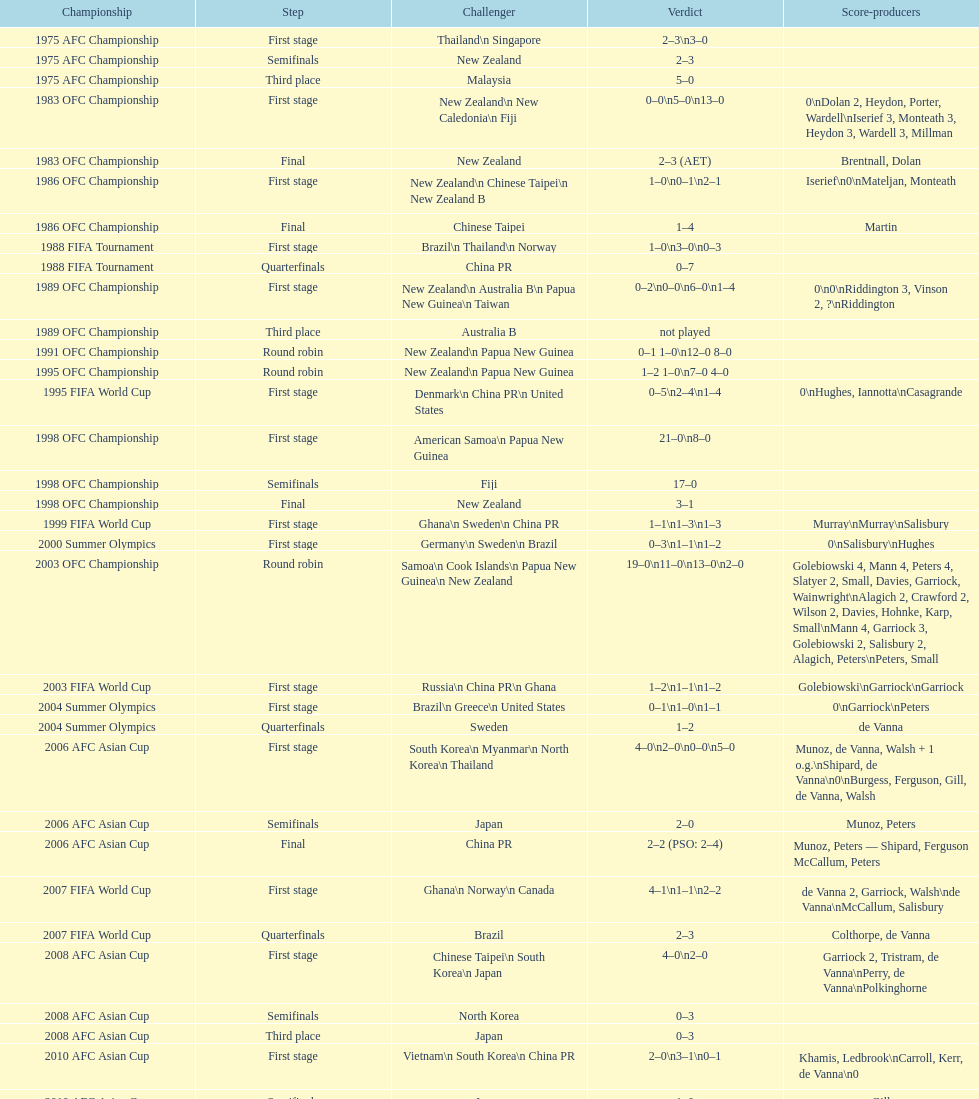How many points were scored in the final round of the 2012 summer olympics afc qualification? 12. Would you mind parsing the complete table? {'header': ['Championship', 'Step', 'Challenger', 'Verdict', 'Score-producers'], 'rows': [['1975 AFC Championship', 'First stage', 'Thailand\\n\xa0Singapore', '2–3\\n3–0', ''], ['1975 AFC Championship', 'Semifinals', 'New Zealand', '2–3', ''], ['1975 AFC Championship', 'Third place', 'Malaysia', '5–0', ''], ['1983 OFC Championship', 'First stage', 'New Zealand\\n\xa0New Caledonia\\n\xa0Fiji', '0–0\\n5–0\\n13–0', '0\\nDolan 2, Heydon, Porter, Wardell\\nIserief 3, Monteath 3, Heydon 3, Wardell 3, Millman'], ['1983 OFC Championship', 'Final', 'New Zealand', '2–3 (AET)', 'Brentnall, Dolan'], ['1986 OFC Championship', 'First stage', 'New Zealand\\n\xa0Chinese Taipei\\n New Zealand B', '1–0\\n0–1\\n2–1', 'Iserief\\n0\\nMateljan, Monteath'], ['1986 OFC Championship', 'Final', 'Chinese Taipei', '1–4', 'Martin'], ['1988 FIFA Tournament', 'First stage', 'Brazil\\n\xa0Thailand\\n\xa0Norway', '1–0\\n3–0\\n0–3', ''], ['1988 FIFA Tournament', 'Quarterfinals', 'China PR', '0–7', ''], ['1989 OFC Championship', 'First stage', 'New Zealand\\n Australia B\\n\xa0Papua New Guinea\\n\xa0Taiwan', '0–2\\n0–0\\n6–0\\n1–4', '0\\n0\\nRiddington 3, Vinson 2,\xa0?\\nRiddington'], ['1989 OFC Championship', 'Third place', 'Australia B', 'not played', ''], ['1991 OFC Championship', 'Round robin', 'New Zealand\\n\xa0Papua New Guinea', '0–1 1–0\\n12–0 8–0', ''], ['1995 OFC Championship', 'Round robin', 'New Zealand\\n\xa0Papua New Guinea', '1–2 1–0\\n7–0 4–0', ''], ['1995 FIFA World Cup', 'First stage', 'Denmark\\n\xa0China PR\\n\xa0United States', '0–5\\n2–4\\n1–4', '0\\nHughes, Iannotta\\nCasagrande'], ['1998 OFC Championship', 'First stage', 'American Samoa\\n\xa0Papua New Guinea', '21–0\\n8–0', ''], ['1998 OFC Championship', 'Semifinals', 'Fiji', '17–0', ''], ['1998 OFC Championship', 'Final', 'New Zealand', '3–1', ''], ['1999 FIFA World Cup', 'First stage', 'Ghana\\n\xa0Sweden\\n\xa0China PR', '1–1\\n1–3\\n1–3', 'Murray\\nMurray\\nSalisbury'], ['2000 Summer Olympics', 'First stage', 'Germany\\n\xa0Sweden\\n\xa0Brazil', '0–3\\n1–1\\n1–2', '0\\nSalisbury\\nHughes'], ['2003 OFC Championship', 'Round robin', 'Samoa\\n\xa0Cook Islands\\n\xa0Papua New Guinea\\n\xa0New Zealand', '19–0\\n11–0\\n13–0\\n2–0', 'Golebiowski 4, Mann 4, Peters 4, Slatyer 2, Small, Davies, Garriock, Wainwright\\nAlagich 2, Crawford 2, Wilson 2, Davies, Hohnke, Karp, Small\\nMann 4, Garriock 3, Golebiowski 2, Salisbury 2, Alagich, Peters\\nPeters, Small'], ['2003 FIFA World Cup', 'First stage', 'Russia\\n\xa0China PR\\n\xa0Ghana', '1–2\\n1–1\\n1–2', 'Golebiowski\\nGarriock\\nGarriock'], ['2004 Summer Olympics', 'First stage', 'Brazil\\n\xa0Greece\\n\xa0United States', '0–1\\n1–0\\n1–1', '0\\nGarriock\\nPeters'], ['2004 Summer Olympics', 'Quarterfinals', 'Sweden', '1–2', 'de Vanna'], ['2006 AFC Asian Cup', 'First stage', 'South Korea\\n\xa0Myanmar\\n\xa0North Korea\\n\xa0Thailand', '4–0\\n2–0\\n0–0\\n5–0', 'Munoz, de Vanna, Walsh + 1 o.g.\\nShipard, de Vanna\\n0\\nBurgess, Ferguson, Gill, de Vanna, Walsh'], ['2006 AFC Asian Cup', 'Semifinals', 'Japan', '2–0', 'Munoz, Peters'], ['2006 AFC Asian Cup', 'Final', 'China PR', '2–2 (PSO: 2–4)', 'Munoz, Peters — Shipard, Ferguson McCallum, Peters'], ['2007 FIFA World Cup', 'First stage', 'Ghana\\n\xa0Norway\\n\xa0Canada', '4–1\\n1–1\\n2–2', 'de Vanna 2, Garriock, Walsh\\nde Vanna\\nMcCallum, Salisbury'], ['2007 FIFA World Cup', 'Quarterfinals', 'Brazil', '2–3', 'Colthorpe, de Vanna'], ['2008 AFC Asian Cup', 'First stage', 'Chinese Taipei\\n\xa0South Korea\\n\xa0Japan', '4–0\\n2–0', 'Garriock 2, Tristram, de Vanna\\nPerry, de Vanna\\nPolkinghorne'], ['2008 AFC Asian Cup', 'Semifinals', 'North Korea', '0–3', ''], ['2008 AFC Asian Cup', 'Third place', 'Japan', '0–3', ''], ['2010 AFC Asian Cup', 'First stage', 'Vietnam\\n\xa0South Korea\\n\xa0China PR', '2–0\\n3–1\\n0–1', 'Khamis, Ledbrook\\nCarroll, Kerr, de Vanna\\n0'], ['2010 AFC Asian Cup', 'Semifinals', 'Japan', '1–0', 'Gill'], ['2010 AFC Asian Cup', 'Final', 'North Korea', '1–1 (PSO: 5–4)', 'Kerr — PSO: Shipard, Ledbrook, Gill, Garriock, Simon'], ['2011 FIFA World Cup', 'First stage', 'Brazil\\n\xa0Equatorial Guinea\\n\xa0Norway', '0–1\\n3–2\\n2–1', '0\\nvan Egmond, Khamis, de Vanna\\nSimon 2'], ['2011 FIFA World Cup', 'Quarterfinals', 'Sweden', '1–3', 'Perry'], ['2012 Summer Olympics\\nAFC qualification', 'Final round', 'North Korea\\n\xa0Thailand\\n\xa0Japan\\n\xa0China PR\\n\xa0South Korea', '0–1\\n5–1\\n0–1\\n1–0\\n2–1', '0\\nHeyman 2, Butt, van Egmond, Simon\\n0\\nvan Egmond\\nButt, de Vanna'], ['2014 AFC Asian Cup', 'First stage', 'Japan\\n\xa0Jordan\\n\xa0Vietnam', 'TBD\\nTBD\\nTBD', '']]} 